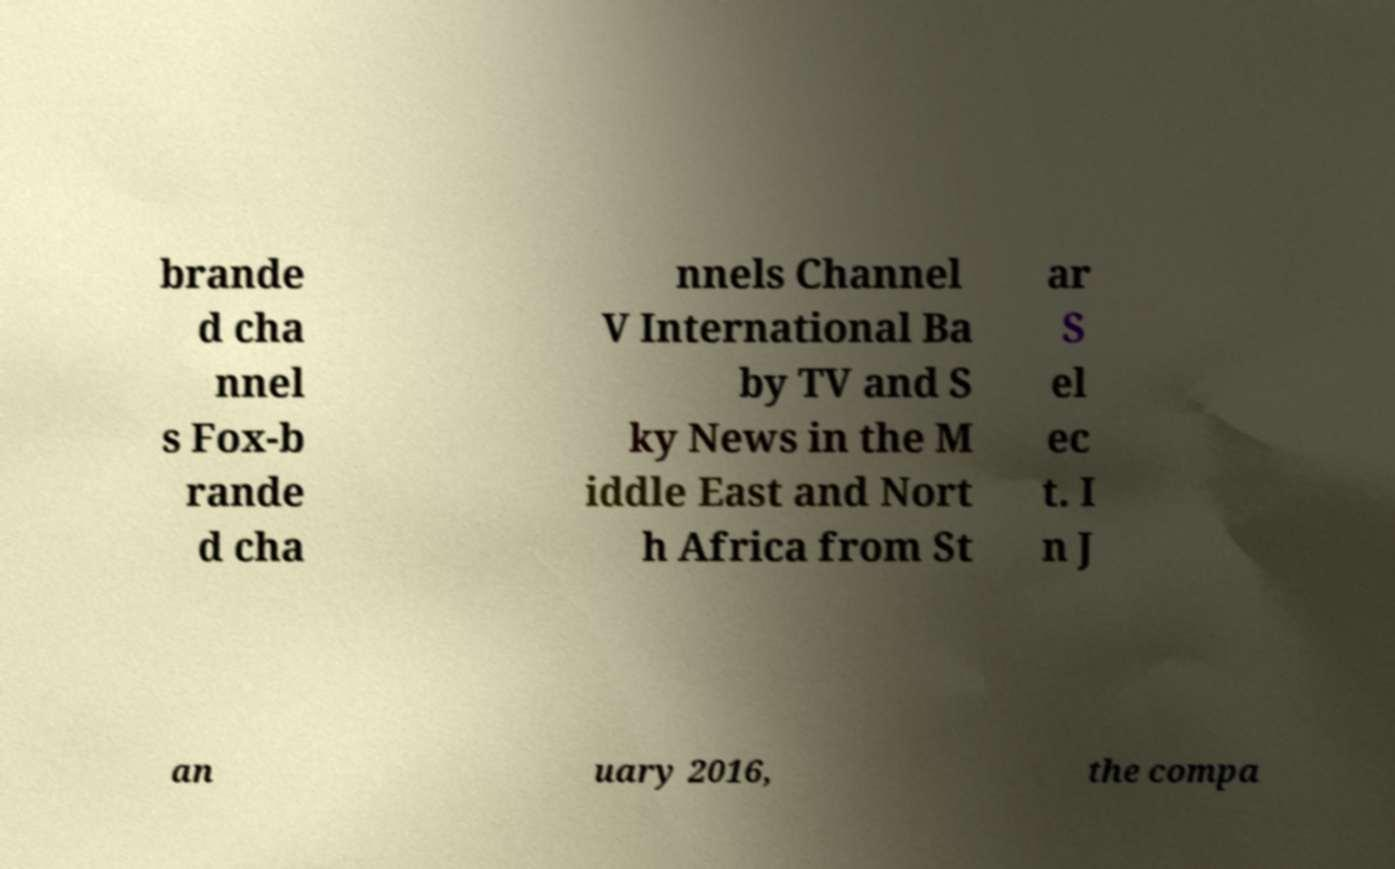I need the written content from this picture converted into text. Can you do that? brande d cha nnel s Fox-b rande d cha nnels Channel V International Ba by TV and S ky News in the M iddle East and Nort h Africa from St ar S el ec t. I n J an uary 2016, the compa 